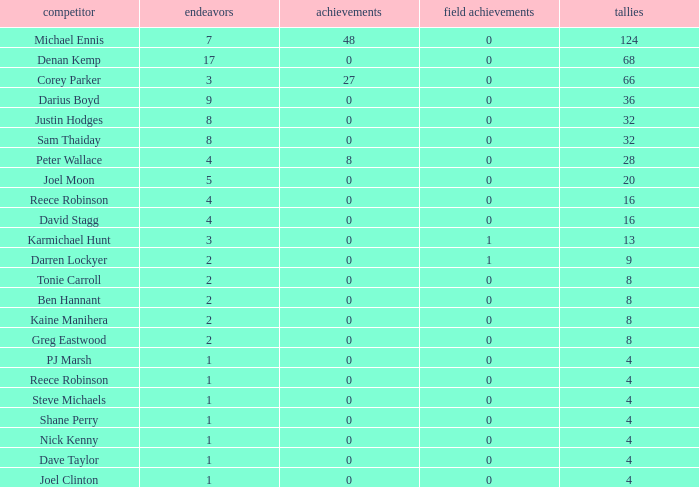How many points did the player with 2 tries and more than 0 field goals have? 9.0. 